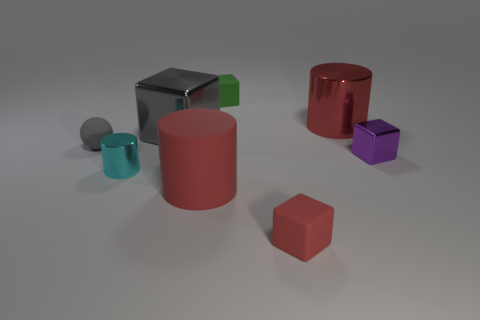The block that is the same color as the large metal cylinder is what size?
Your answer should be very brief. Small. There is a large metal object in front of the red metallic cylinder; does it have the same shape as the object left of the small cylinder?
Offer a terse response. No. Are any blocks visible?
Offer a very short reply. Yes. The shiny cylinder that is the same size as the purple metal cube is what color?
Ensure brevity in your answer.  Cyan. What number of purple objects are the same shape as the small red object?
Your response must be concise. 1. Do the large cylinder left of the green block and the gray block have the same material?
Offer a very short reply. No. How many cylinders are either green matte things or tiny metallic objects?
Provide a succinct answer. 1. What shape is the large thing that is on the right side of the cylinder in front of the tiny shiny thing left of the small red object?
Provide a short and direct response. Cylinder. There is a thing that is the same color as the large metallic block; what shape is it?
Give a very brief answer. Sphere. What number of other red objects have the same size as the red metal object?
Provide a succinct answer. 1. 